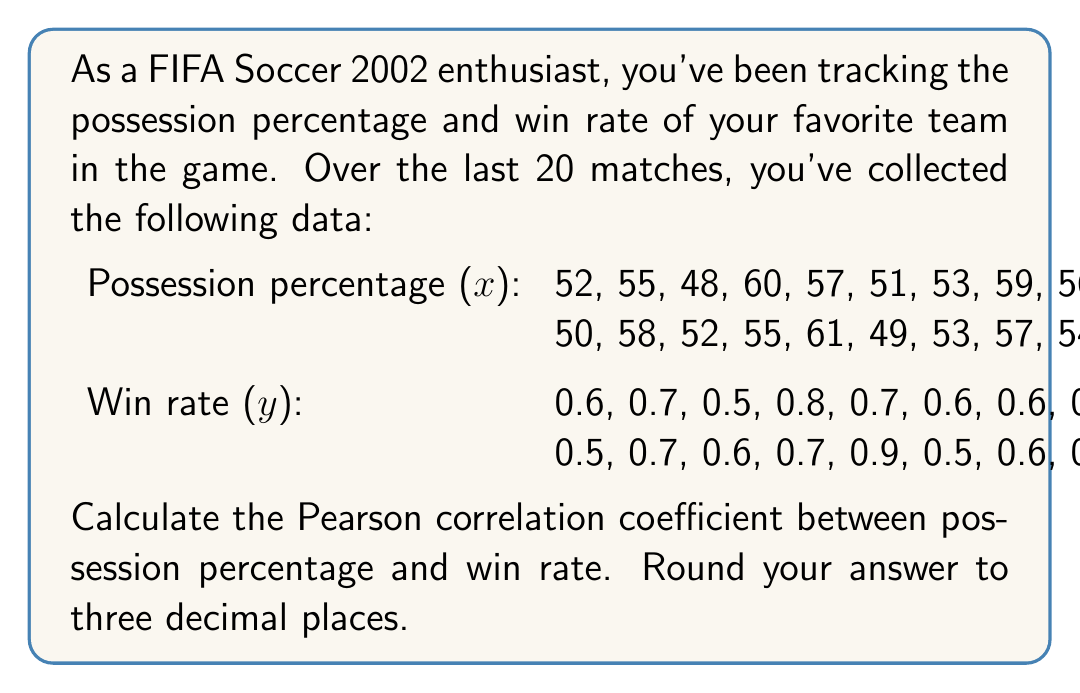Show me your answer to this math problem. To calculate the Pearson correlation coefficient (r) between possession percentage (x) and win rate (y), we'll use the formula:

$$ r = \frac{\sum_{i=1}^{n} (x_i - \bar{x})(y_i - \bar{y})}{\sqrt{\sum_{i=1}^{n} (x_i - \bar{x})^2 \sum_{i=1}^{n} (y_i - \bar{y})^2}} $$

Where $\bar{x}$ and $\bar{y}$ are the means of x and y respectively.

Step 1: Calculate the means
$\bar{x} = \frac{\sum x_i}{n} = \frac{1090}{20} = 54.5$
$\bar{y} = \frac{\sum y_i}{n} = \frac{13.3}{20} = 0.665$

Step 2: Calculate the numerator $\sum_{i=1}^{n} (x_i - \bar{x})(y_i - \bar{y})$
$\sum_{i=1}^{n} (x_i - \bar{x})(y_i - \bar{y}) = 16.225$

Step 3: Calculate $\sum_{i=1}^{n} (x_i - \bar{x})^2$
$\sum_{i=1}^{n} (x_i - \bar{x})^2 = 422.5$

Step 4: Calculate $\sum_{i=1}^{n} (y_i - \bar{y})^2$
$\sum_{i=1}^{n} (y_i - \bar{y})^2 = 0.2655$

Step 5: Calculate r
$$ r = \frac{16.225}{\sqrt{422.5 \times 0.2655}} = \frac{16.225}{10.596} = 0.9781 $$

Step 6: Round to three decimal places
$r \approx 0.978$
Answer: 0.978 